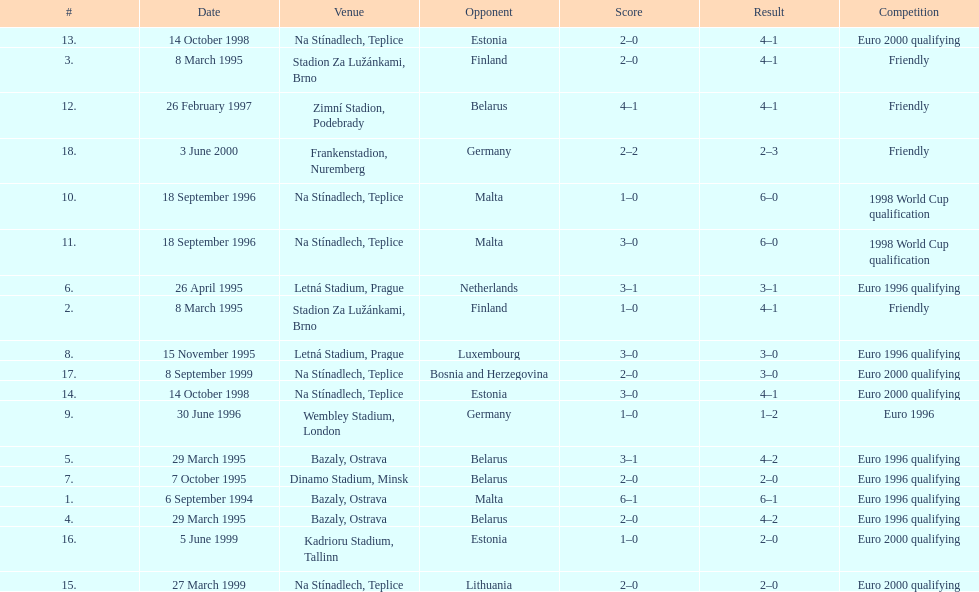Could you help me parse every detail presented in this table? {'header': ['#', 'Date', 'Venue', 'Opponent', 'Score', 'Result', 'Competition'], 'rows': [['13.', '14 October 1998', 'Na Stínadlech, Teplice', 'Estonia', '2–0', '4–1', 'Euro 2000 qualifying'], ['3.', '8 March 1995', 'Stadion Za Lužánkami, Brno', 'Finland', '2–0', '4–1', 'Friendly'], ['12.', '26 February 1997', 'Zimní Stadion, Podebrady', 'Belarus', '4–1', '4–1', 'Friendly'], ['18.', '3 June 2000', 'Frankenstadion, Nuremberg', 'Germany', '2–2', '2–3', 'Friendly'], ['10.', '18 September 1996', 'Na Stínadlech, Teplice', 'Malta', '1–0', '6–0', '1998 World Cup qualification'], ['11.', '18 September 1996', 'Na Stínadlech, Teplice', 'Malta', '3–0', '6–0', '1998 World Cup qualification'], ['6.', '26 April 1995', 'Letná Stadium, Prague', 'Netherlands', '3–1', '3–1', 'Euro 1996 qualifying'], ['2.', '8 March 1995', 'Stadion Za Lužánkami, Brno', 'Finland', '1–0', '4–1', 'Friendly'], ['8.', '15 November 1995', 'Letná Stadium, Prague', 'Luxembourg', '3–0', '3–0', 'Euro 1996 qualifying'], ['17.', '8 September 1999', 'Na Stínadlech, Teplice', 'Bosnia and Herzegovina', '2–0', '3–0', 'Euro 2000 qualifying'], ['14.', '14 October 1998', 'Na Stínadlech, Teplice', 'Estonia', '3–0', '4–1', 'Euro 2000 qualifying'], ['9.', '30 June 1996', 'Wembley Stadium, London', 'Germany', '1–0', '1–2', 'Euro 1996'], ['5.', '29 March 1995', 'Bazaly, Ostrava', 'Belarus', '3–1', '4–2', 'Euro 1996 qualifying'], ['7.', '7 October 1995', 'Dinamo Stadium, Minsk', 'Belarus', '2–0', '2–0', 'Euro 1996 qualifying'], ['1.', '6 September 1994', 'Bazaly, Ostrava', 'Malta', '6–1', '6–1', 'Euro 1996 qualifying'], ['4.', '29 March 1995', 'Bazaly, Ostrava', 'Belarus', '2–0', '4–2', 'Euro 1996 qualifying'], ['16.', '5 June 1999', 'Kadrioru Stadium, Tallinn', 'Estonia', '1–0', '2–0', 'Euro 2000 qualifying'], ['15.', '27 March 1999', 'Na Stínadlech, Teplice', 'Lithuania', '2–0', '2–0', 'Euro 2000 qualifying']]} Which team did czech republic score the most goals against? Malta. 